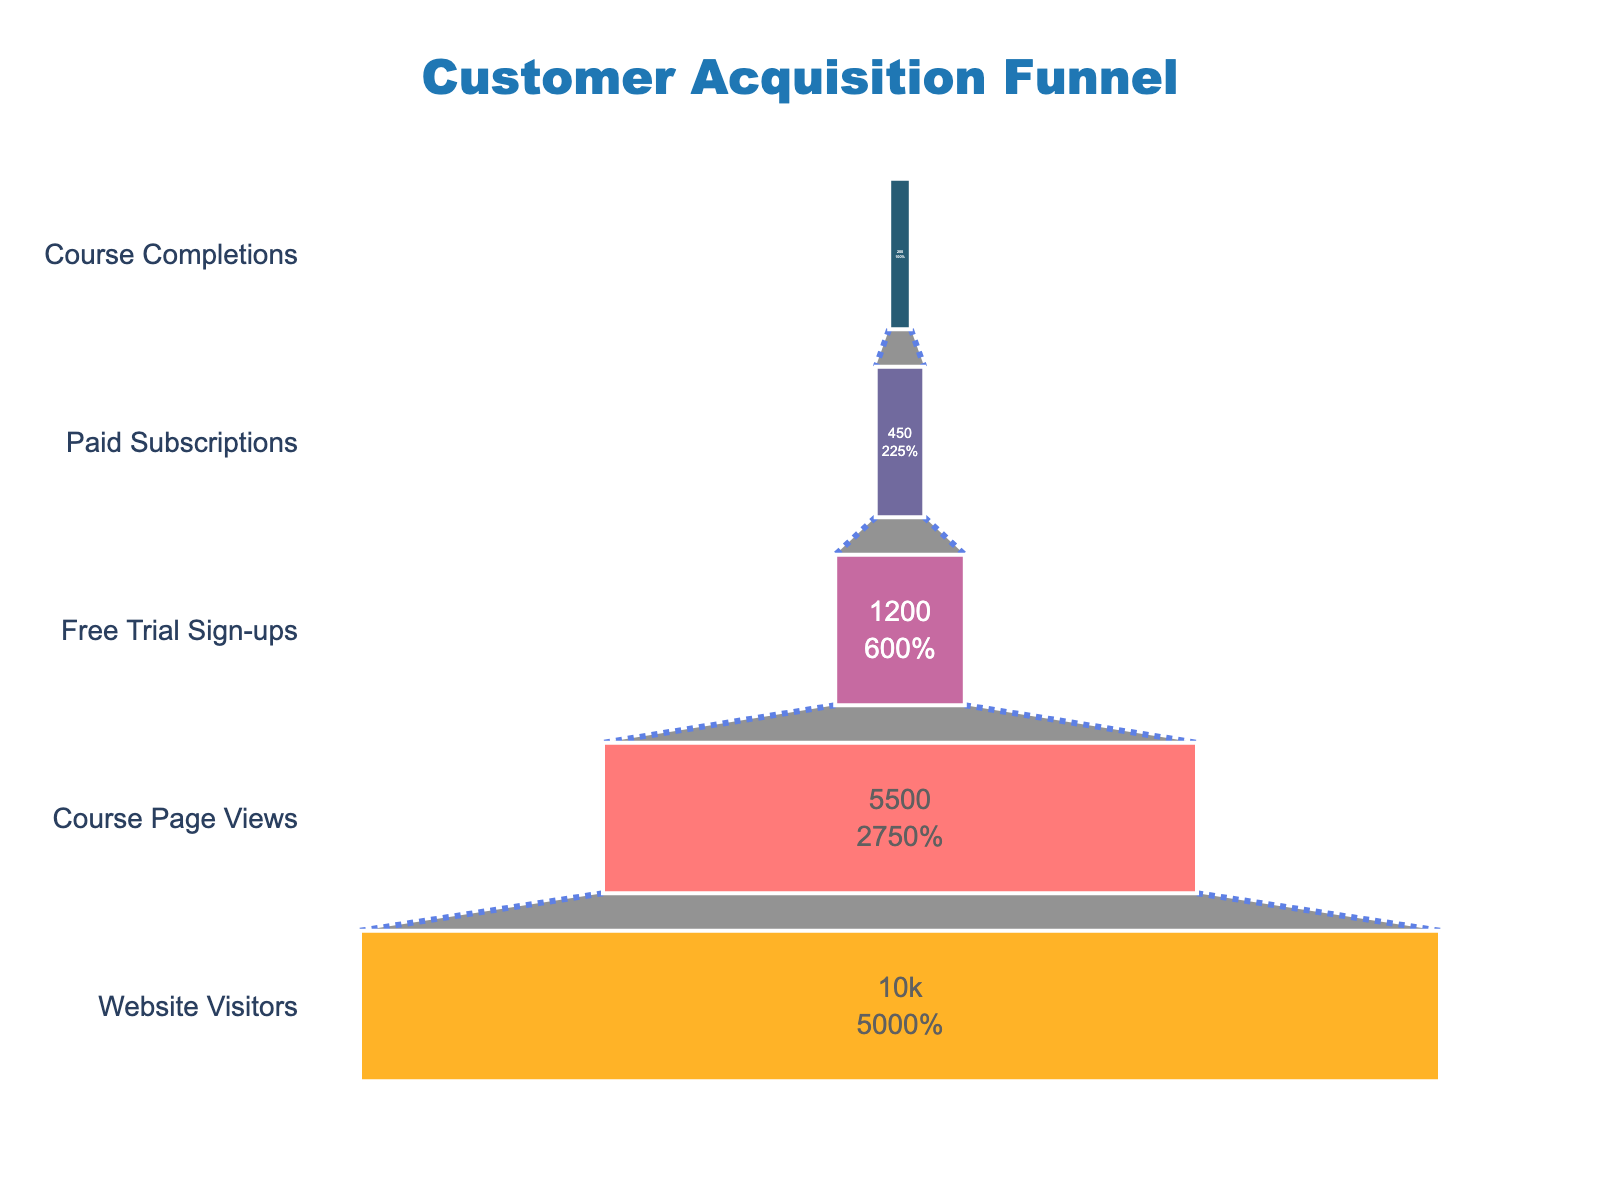what's the title of the funnel chart? The title of the funnel chart is displayed at the top of the chart. It reads "Customer Acquisition Funnel".
Answer: Customer Acquisition Funnel how many stages are there in the funnel? We can count the distinct stages listed on the y-axis of the funnel chart. The stages are "Website Visitors", "Course Page Views", "Free Trial Sign-ups", "Paid Subscriptions", and "Course Completions".
Answer: 5 what percentage of users signed up for the free trial from those who viewed the course page? From the chart, 5500 users viewed the course page and 1200 users signed up for the free trial. The percentage is calculated as (1200 / 5500) * 100.
Answer: 21.82% how many more users viewed the course page than signed up for the free trial? The number of users who viewed the course page is 5500 and those who signed up for the free trial is 1200. The difference is 5500 - 1200.
Answer: 4300 what's the conversion rate from website visitors to paid subscriptions? Conversion rate is calculated as the number of paid subscriptions divided by the number of website visitors, then multiplied by 100. Here, it's (450 / 10000) * 100.
Answer: 4.5% which stage has the highest drop-off from the previous stage? By calculating the drop-off between each stage: Website Visitors to Course Page Views: 10000 - 5500 = 4500, Course Page Views to Free Trial Sign-ups: 5500 - 1200 = 4300, Free Trial Sign-ups to Paid Subscriptions: 1200 - 450 = 750, Paid Subscriptions to Course Completions: 450 - 200 = 250. The largest drop-off is between Website Visitors and Course Page Views.
Answer: Website Visitors to Course Page Views what's the percentage of users who completed the course out of those who started a free trial? The percentage is calculated as the number of course completions divided by free trial sign-ups, then multiplied by 100. Here, it's (200 / 1200) * 100.
Answer: 16.67% compare the number of users who signed up for a paid subscription to those who completed the course? The number of users who signed up for a paid subscription is 450 and the number who completed the course is 200. Comparison shows 450 is greater than 200.
Answer: Paid Subscriptions > Course Completions 